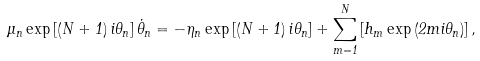Convert formula to latex. <formula><loc_0><loc_0><loc_500><loc_500>\mu _ { n } \exp \left [ \left ( N + 1 \right ) i \theta _ { n } \right ] \dot { \theta } _ { n } = - \eta _ { n } \exp \left [ \left ( N + 1 \right ) i \theta _ { n } \right ] + \sum _ { m = 1 } ^ { N } \left [ h _ { m } \exp \left ( 2 m i \theta _ { n } \right ) \right ] ,</formula> 